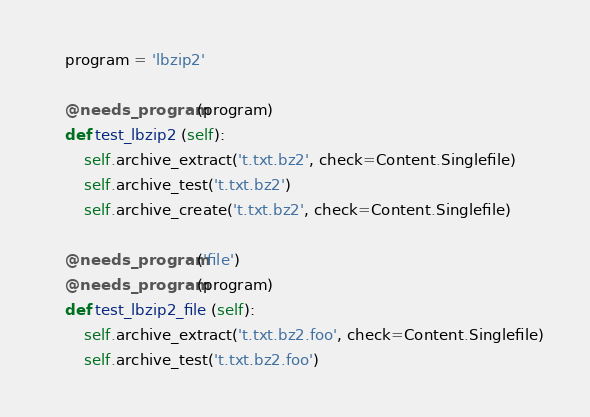<code> <loc_0><loc_0><loc_500><loc_500><_Python_>
    program = 'lbzip2'

    @needs_program(program)
    def test_lbzip2 (self):
        self.archive_extract('t.txt.bz2', check=Content.Singlefile)
        self.archive_test('t.txt.bz2')
        self.archive_create('t.txt.bz2', check=Content.Singlefile)

    @needs_program('file')
    @needs_program(program)
    def test_lbzip2_file (self):
        self.archive_extract('t.txt.bz2.foo', check=Content.Singlefile)
        self.archive_test('t.txt.bz2.foo')

</code> 